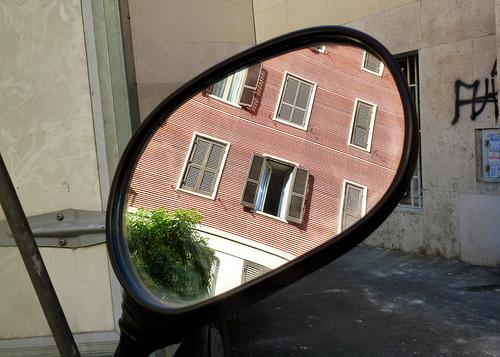Question: what color is the graffiti?
Choices:
A. Black.
B. White.
C. Red.
D. Yellow.
Answer with the letter. Answer: A Question: what color is the ground?
Choices:
A. Black.
B. Yellow.
C. Green.
D. Grey.
Answer with the letter. Answer: D Question: how many mirrors are in the picture?
Choices:
A. Two.
B. Three.
C. Four.
D. One.
Answer with the letter. Answer: D Question: who is in the picture?
Choices:
A. There are no people in the image.
B. The baseball team.
C. The football team.
D. The soccer team.
Answer with the letter. Answer: A 